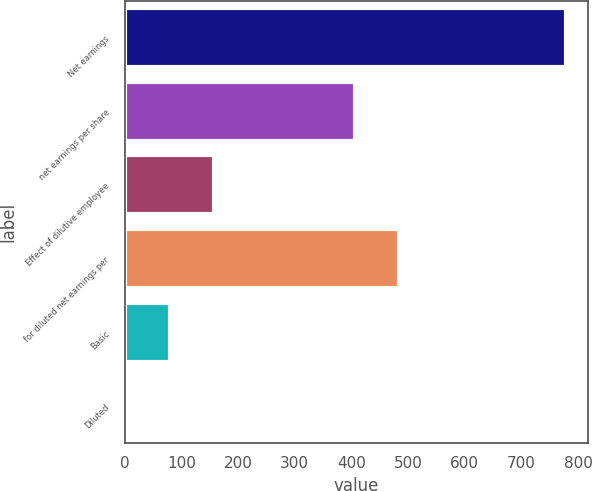Convert chart. <chart><loc_0><loc_0><loc_500><loc_500><bar_chart><fcel>Net earnings<fcel>net earnings per share<fcel>Effect of dilutive employee<fcel>for diluted net earnings per<fcel>Basic<fcel>Diluted<nl><fcel>777.7<fcel>406.5<fcel>157.05<fcel>484.08<fcel>79.47<fcel>1.89<nl></chart> 